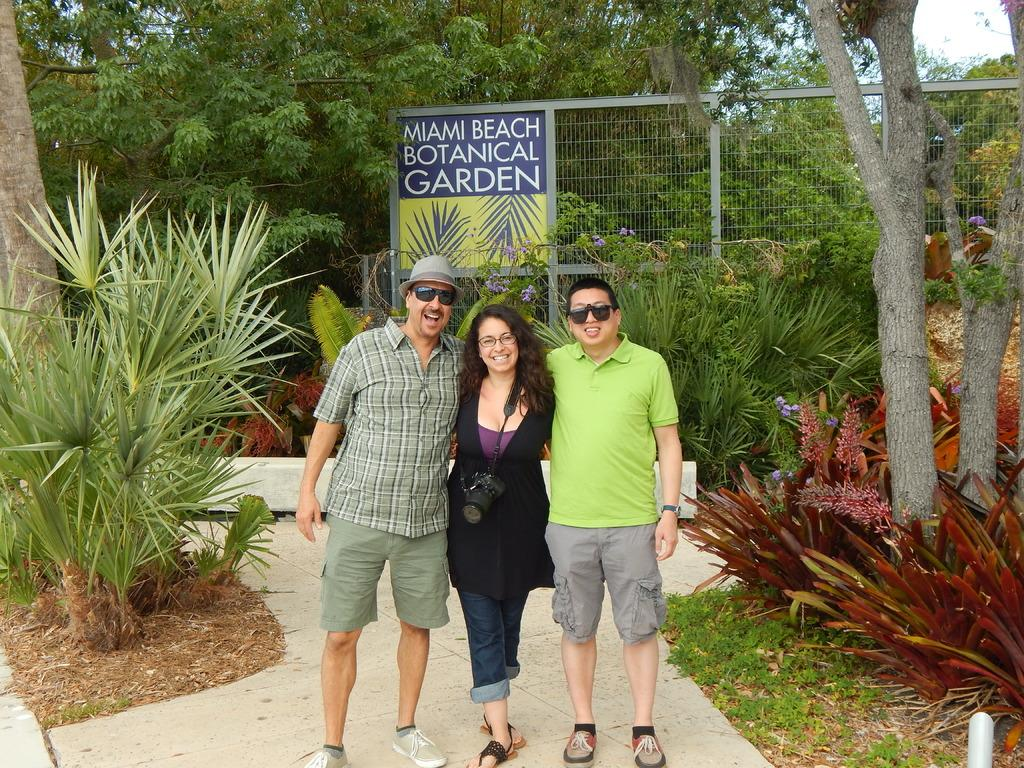How many people are present in the image? There are three people standing in the image. What is the woman wearing in the image? The woman is wearing a camera in the image. What type of vegetation can be seen in the image? There are plants and trees visible in the image. What is attached to the fence in the image? There is a board on a fence in the image. What is visible in the background of the image? The sky and trees are visible in the background of the image. What type of hospital can be seen in the background of the image? There is no hospital present in the image; only trees and the sky are visible in the background. How many branches are visible on the trees in the image? The image does not provide enough detail to count the number of branches on the trees. 